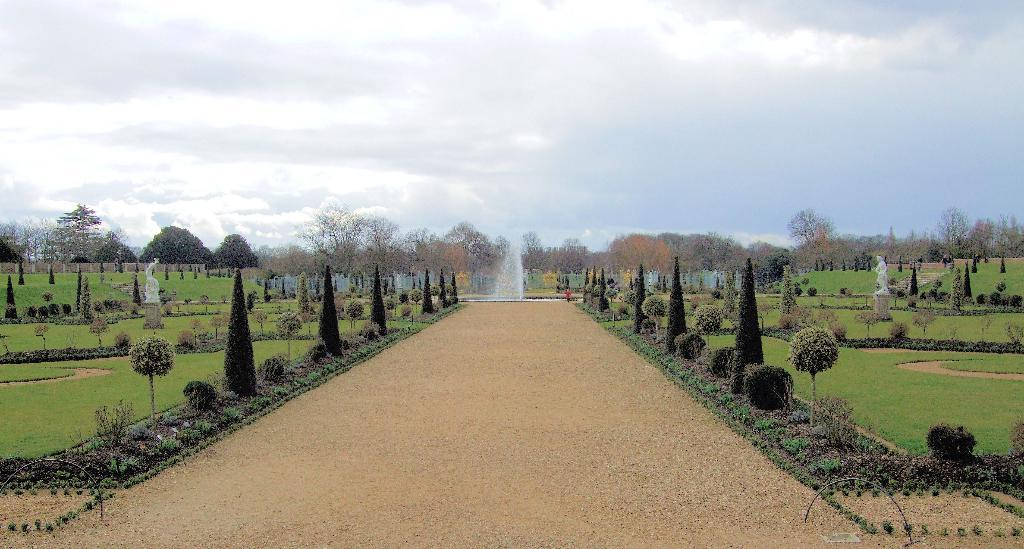What type of vegetation is present in the image? There are trees in the image. What is the ground covered with in the image? There is grass in the image. What water feature can be seen in the image? There is a fountain in the image. What type of structures are present in the image? There are white color statues in the image. What is the color of the sky in the image? The sky is blue and white in color. What type of soap is being used to clean the statues in the image? There is no soap or cleaning activity depicted in the image; it only shows the statues and other elements. What story is being told by the statues in the image? The statues in the image are not telling a story; they are simply present as part of the scene. 